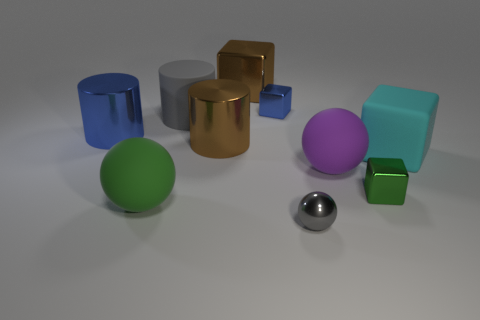Is the number of cyan things less than the number of things?
Offer a very short reply. Yes. What shape is the gray object that is behind the green thing left of the matte cylinder in front of the brown cube?
Ensure brevity in your answer.  Cylinder. There is a thing that is the same color as the large metal cube; what shape is it?
Ensure brevity in your answer.  Cylinder. Is there a small gray matte sphere?
Give a very brief answer. No. Is the size of the blue cylinder the same as the matte sphere left of the big brown cube?
Provide a succinct answer. Yes. There is a object in front of the big green rubber thing; are there any tiny spheres in front of it?
Provide a short and direct response. No. What is the thing that is in front of the purple rubber object and on the left side of the small blue metallic cube made of?
Give a very brief answer. Rubber. There is a tiny thing that is to the left of the tiny metallic object that is in front of the small metallic cube in front of the cyan matte thing; what is its color?
Provide a succinct answer. Blue. The other block that is the same size as the green metal cube is what color?
Offer a very short reply. Blue. Do the shiny ball and the tiny shiny object to the right of the small gray thing have the same color?
Your answer should be compact. No. 